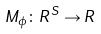Convert formula to latex. <formula><loc_0><loc_0><loc_500><loc_500>M _ { \phi } \colon R ^ { S } \rightarrow R</formula> 